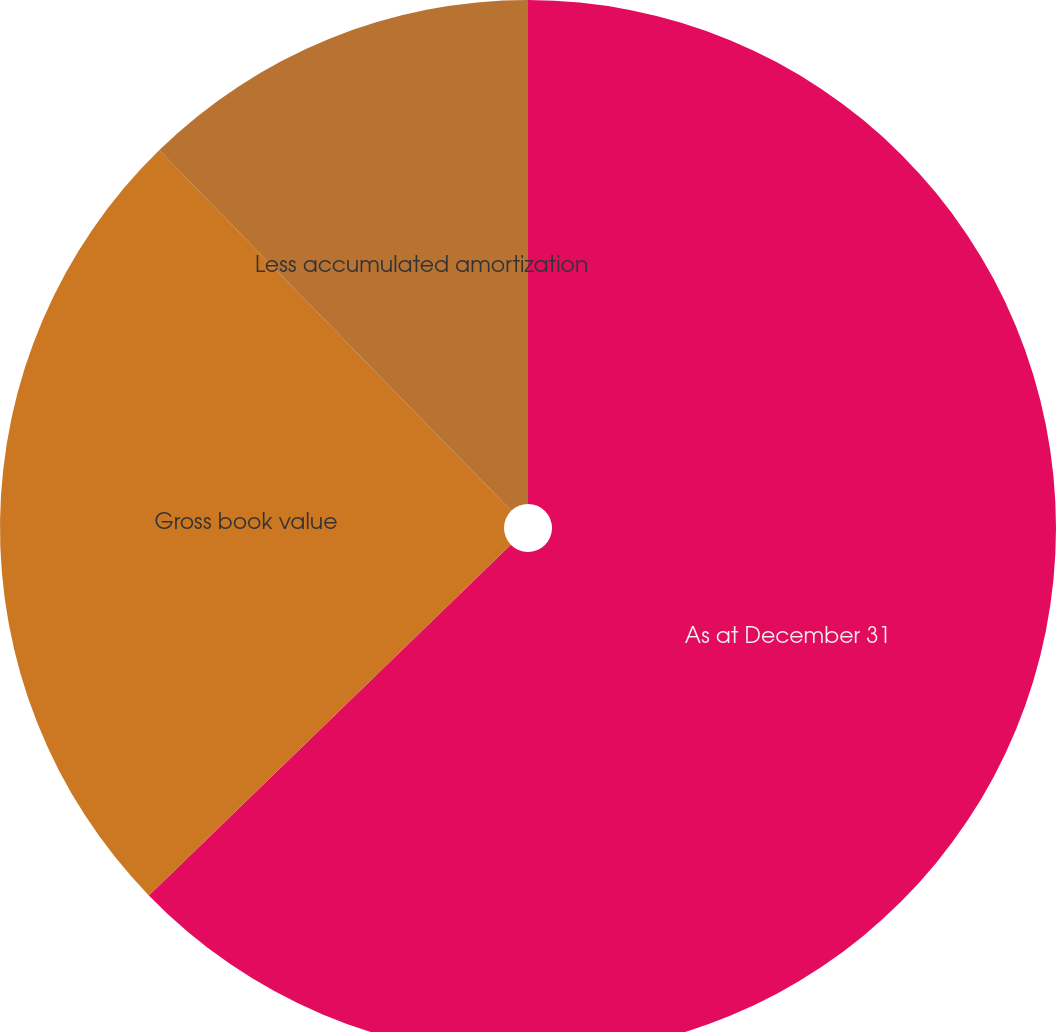Convert chart to OTSL. <chart><loc_0><loc_0><loc_500><loc_500><pie_chart><fcel>As at December 31<fcel>Gross book value<fcel>Less accumulated amortization<nl><fcel>62.75%<fcel>24.94%<fcel>12.31%<nl></chart> 